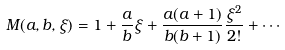Convert formula to latex. <formula><loc_0><loc_0><loc_500><loc_500>M ( a , b , \xi ) = 1 + \frac { a } { b } \xi + \frac { a ( a + 1 ) } { b ( b + 1 ) } \frac { \xi ^ { 2 } } { 2 ! } + \cdots</formula> 